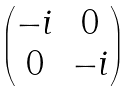Convert formula to latex. <formula><loc_0><loc_0><loc_500><loc_500>\begin{pmatrix} - i & 0 \\ 0 & - i \end{pmatrix}</formula> 